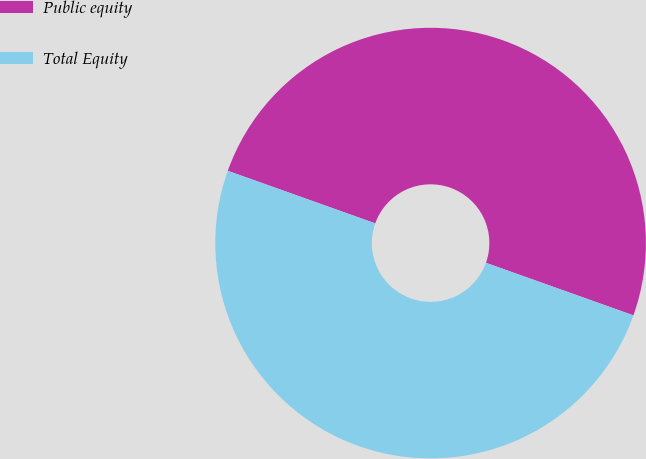<chart> <loc_0><loc_0><loc_500><loc_500><pie_chart><fcel>Public equity<fcel>Total Equity<nl><fcel>50.0%<fcel>50.0%<nl></chart> 